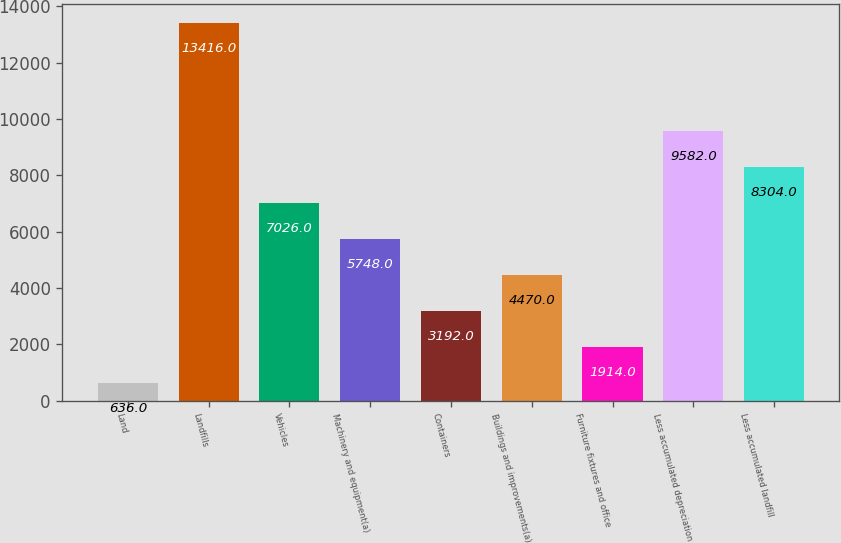Convert chart to OTSL. <chart><loc_0><loc_0><loc_500><loc_500><bar_chart><fcel>Land<fcel>Landfills<fcel>Vehicles<fcel>Machinery and equipment(a)<fcel>Containers<fcel>Buildings and improvements(a)<fcel>Furniture fixtures and office<fcel>Less accumulated depreciation<fcel>Less accumulated landfill<nl><fcel>636<fcel>13416<fcel>7026<fcel>5748<fcel>3192<fcel>4470<fcel>1914<fcel>9582<fcel>8304<nl></chart> 